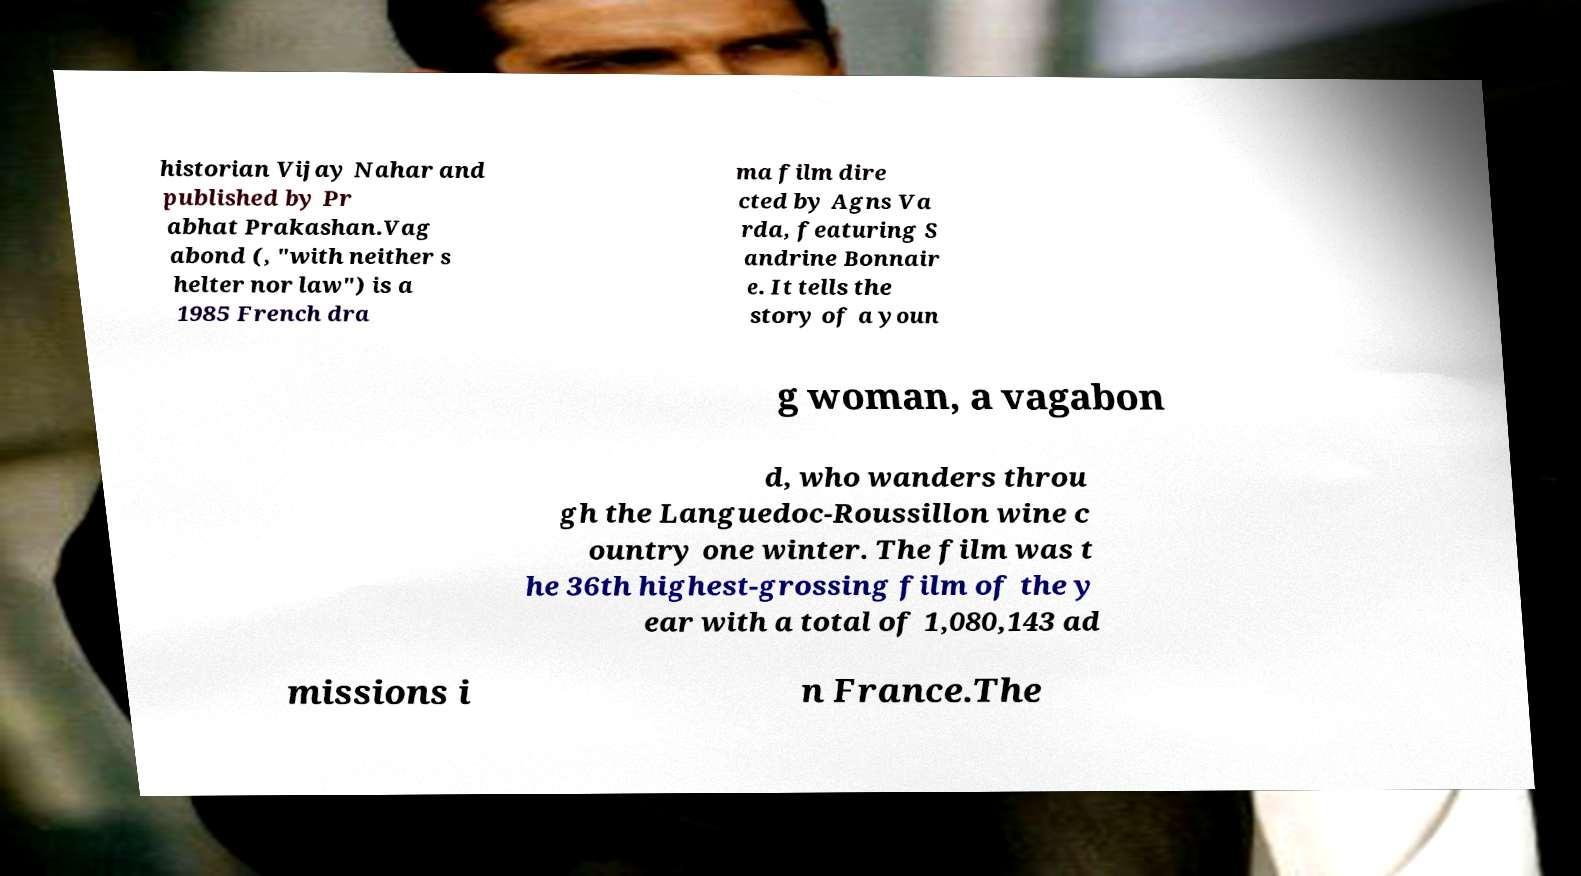Can you accurately transcribe the text from the provided image for me? historian Vijay Nahar and published by Pr abhat Prakashan.Vag abond (, "with neither s helter nor law") is a 1985 French dra ma film dire cted by Agns Va rda, featuring S andrine Bonnair e. It tells the story of a youn g woman, a vagabon d, who wanders throu gh the Languedoc-Roussillon wine c ountry one winter. The film was t he 36th highest-grossing film of the y ear with a total of 1,080,143 ad missions i n France.The 